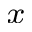Convert formula to latex. <formula><loc_0><loc_0><loc_500><loc_500>_ { x }</formula> 